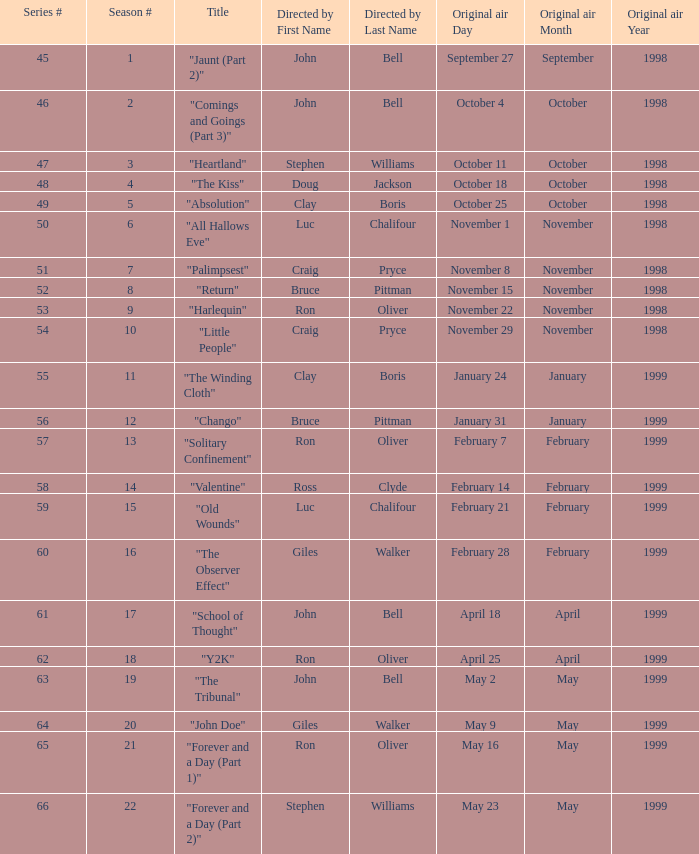Which Season # has a Title of "jaunt (part 2)", and a Series # larger than 45? None. 